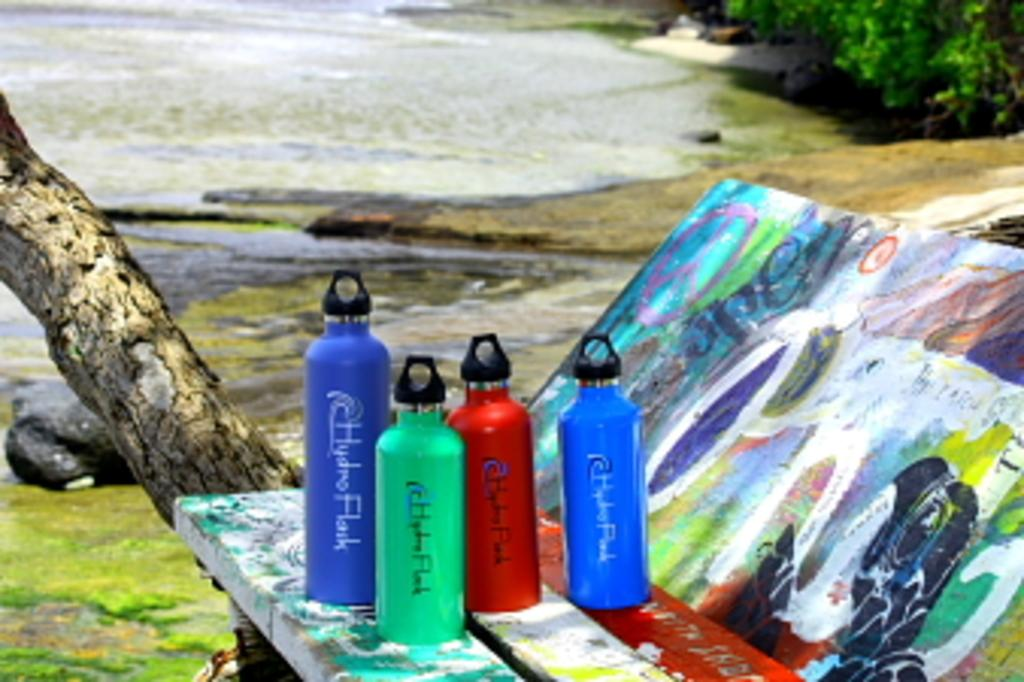<image>
Share a concise interpretation of the image provided. Different colored water bottles are lined up together with the word hydro on them. 